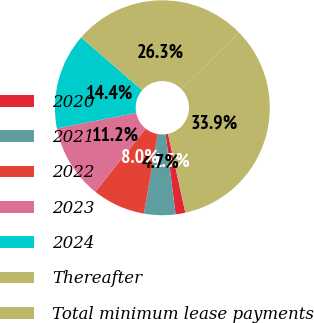<chart> <loc_0><loc_0><loc_500><loc_500><pie_chart><fcel>2020<fcel>2021<fcel>2022<fcel>2023<fcel>2024<fcel>Thereafter<fcel>Total minimum lease payments<nl><fcel>1.47%<fcel>4.72%<fcel>7.96%<fcel>11.21%<fcel>14.45%<fcel>26.27%<fcel>33.92%<nl></chart> 